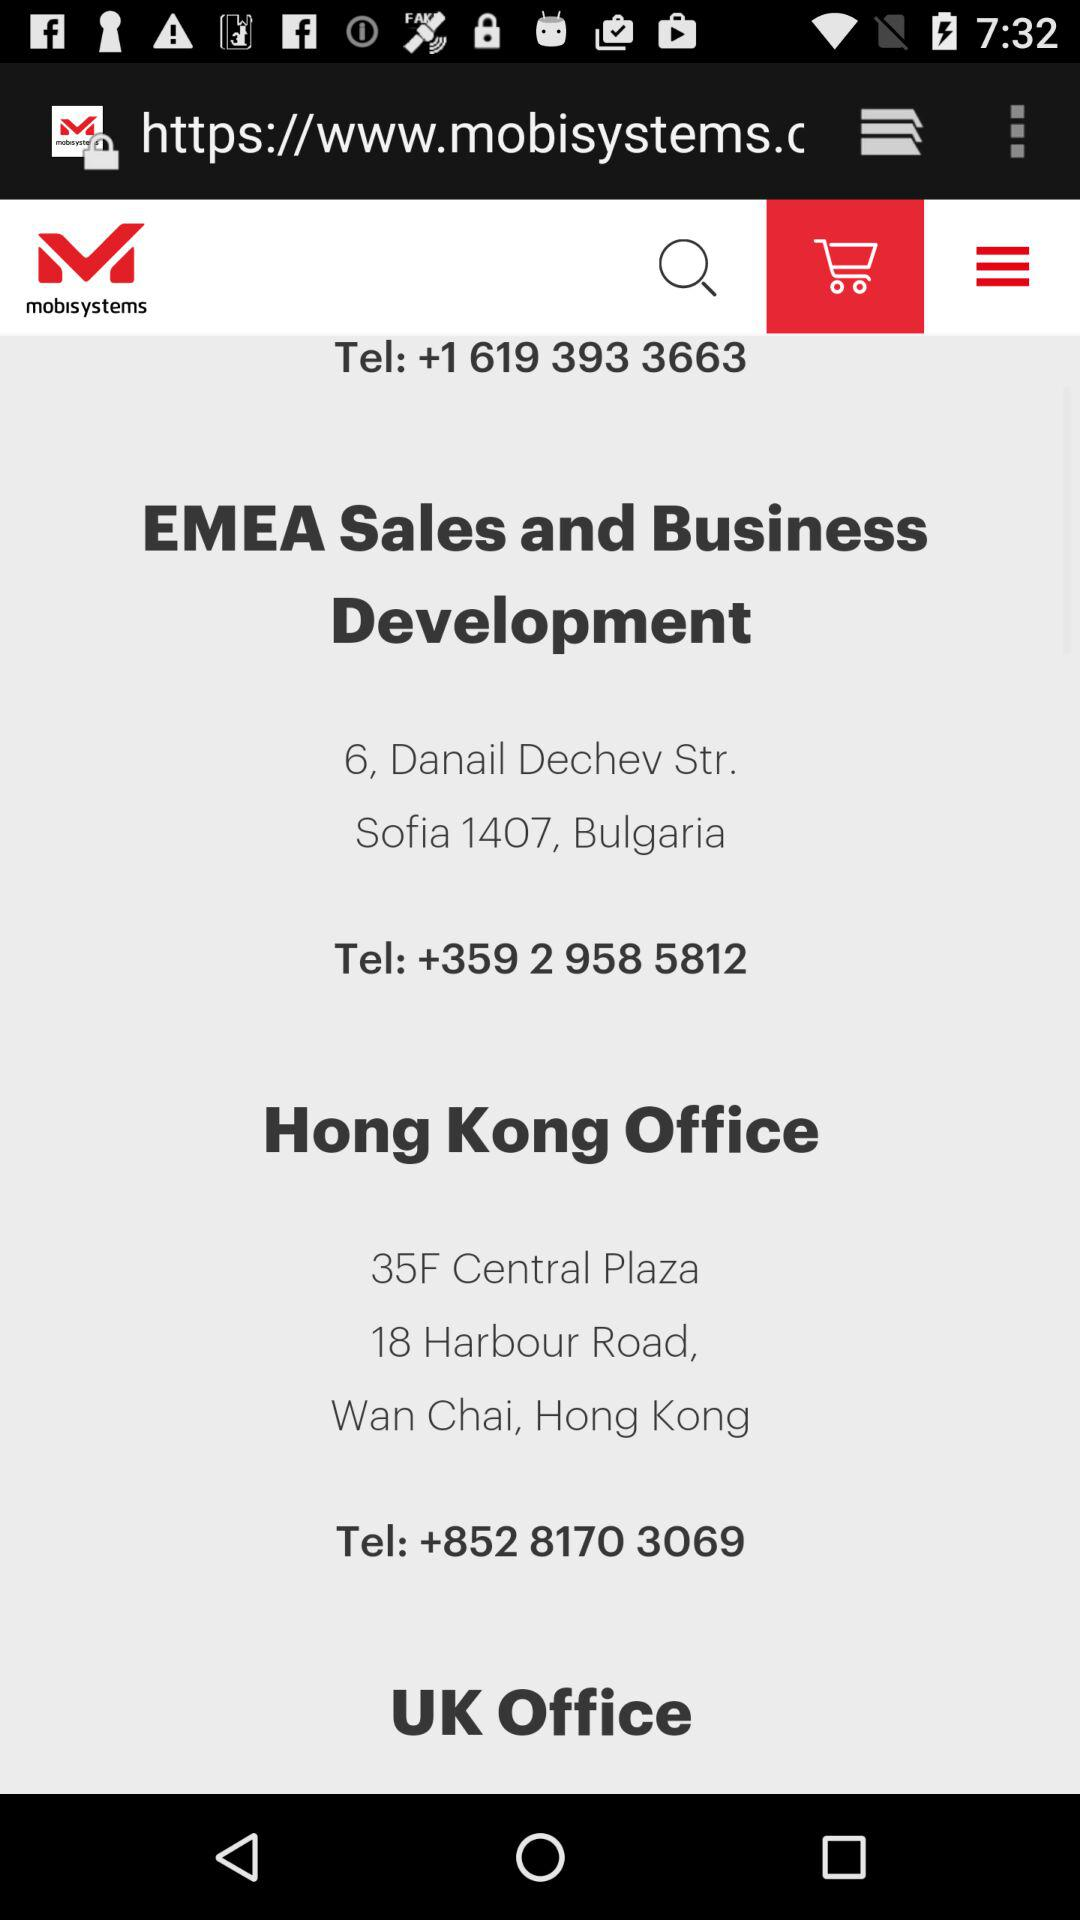What is the address of "Hong Kong Office"? The address is 35F Central Plaza, 18 Harbour Road, Wan Chai, Hong Kong. 